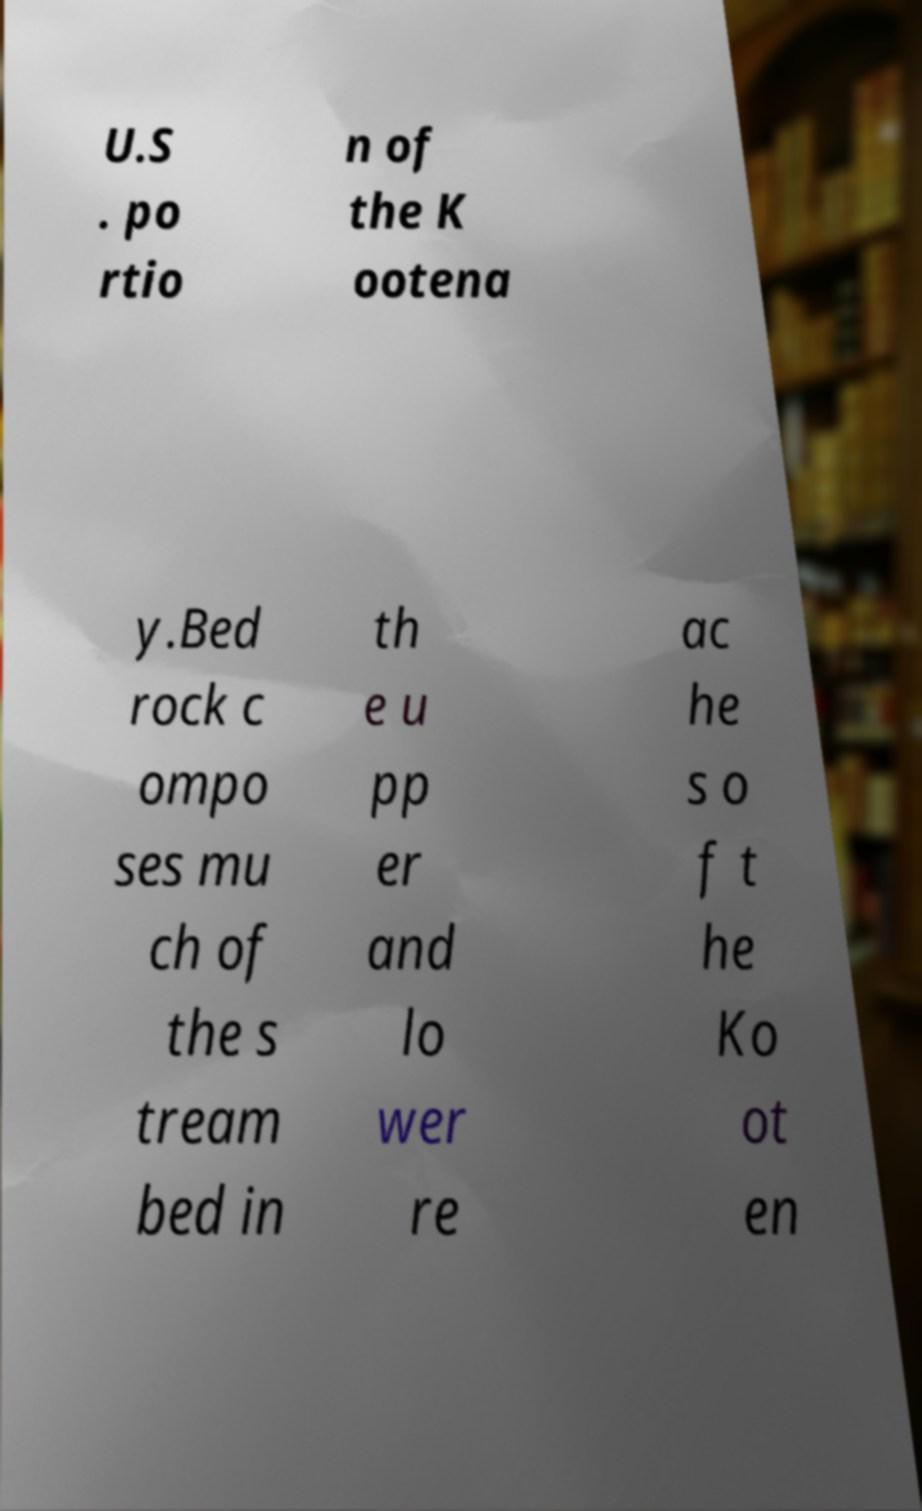I need the written content from this picture converted into text. Can you do that? U.S . po rtio n of the K ootena y.Bed rock c ompo ses mu ch of the s tream bed in th e u pp er and lo wer re ac he s o f t he Ko ot en 